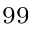Convert formula to latex. <formula><loc_0><loc_0><loc_500><loc_500>^ { 9 9 }</formula> 